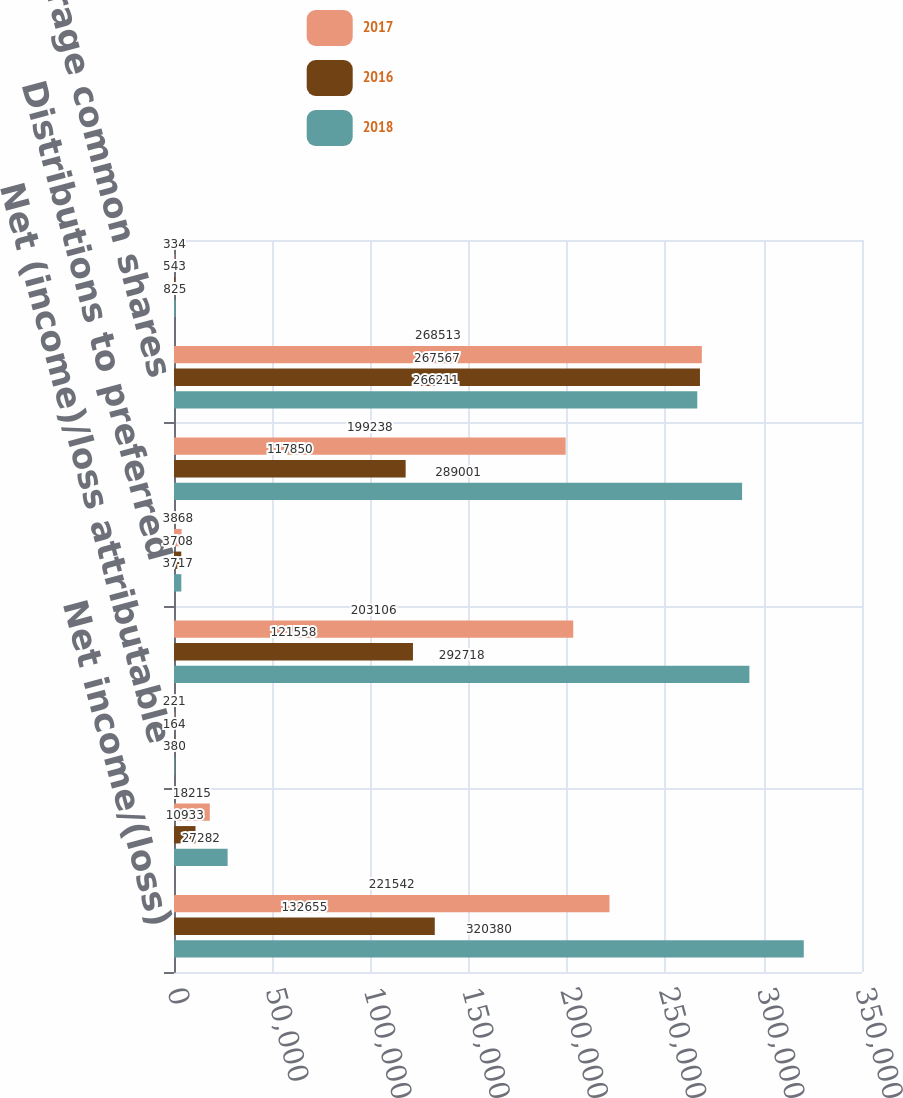Convert chart. <chart><loc_0><loc_0><loc_500><loc_500><stacked_bar_chart><ecel><fcel>Net income/(loss)<fcel>Partnership and DownREIT<fcel>Net (income)/loss attributable<fcel>Net income/(loss) attributable<fcel>Distributions to preferred<fcel>Income/(loss) attributable to<fcel>Weighted average common shares<fcel>Non-vested restricted stock<nl><fcel>2017<fcel>221542<fcel>18215<fcel>221<fcel>203106<fcel>3868<fcel>199238<fcel>268513<fcel>334<nl><fcel>2016<fcel>132655<fcel>10933<fcel>164<fcel>121558<fcel>3708<fcel>117850<fcel>267567<fcel>543<nl><fcel>2018<fcel>320380<fcel>27282<fcel>380<fcel>292718<fcel>3717<fcel>289001<fcel>266211<fcel>825<nl></chart> 